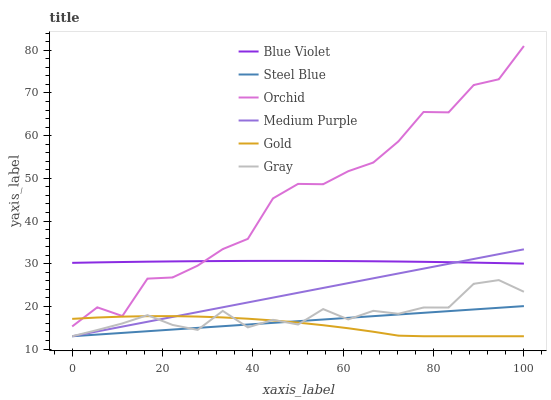Does Gold have the minimum area under the curve?
Answer yes or no. Yes. Does Orchid have the maximum area under the curve?
Answer yes or no. Yes. Does Steel Blue have the minimum area under the curve?
Answer yes or no. No. Does Steel Blue have the maximum area under the curve?
Answer yes or no. No. Is Steel Blue the smoothest?
Answer yes or no. Yes. Is Orchid the roughest?
Answer yes or no. Yes. Is Gold the smoothest?
Answer yes or no. No. Is Gold the roughest?
Answer yes or no. No. Does Gray have the lowest value?
Answer yes or no. Yes. Does Blue Violet have the lowest value?
Answer yes or no. No. Does Orchid have the highest value?
Answer yes or no. Yes. Does Steel Blue have the highest value?
Answer yes or no. No. Is Steel Blue less than Orchid?
Answer yes or no. Yes. Is Blue Violet greater than Steel Blue?
Answer yes or no. Yes. Does Gold intersect Orchid?
Answer yes or no. Yes. Is Gold less than Orchid?
Answer yes or no. No. Is Gold greater than Orchid?
Answer yes or no. No. Does Steel Blue intersect Orchid?
Answer yes or no. No. 